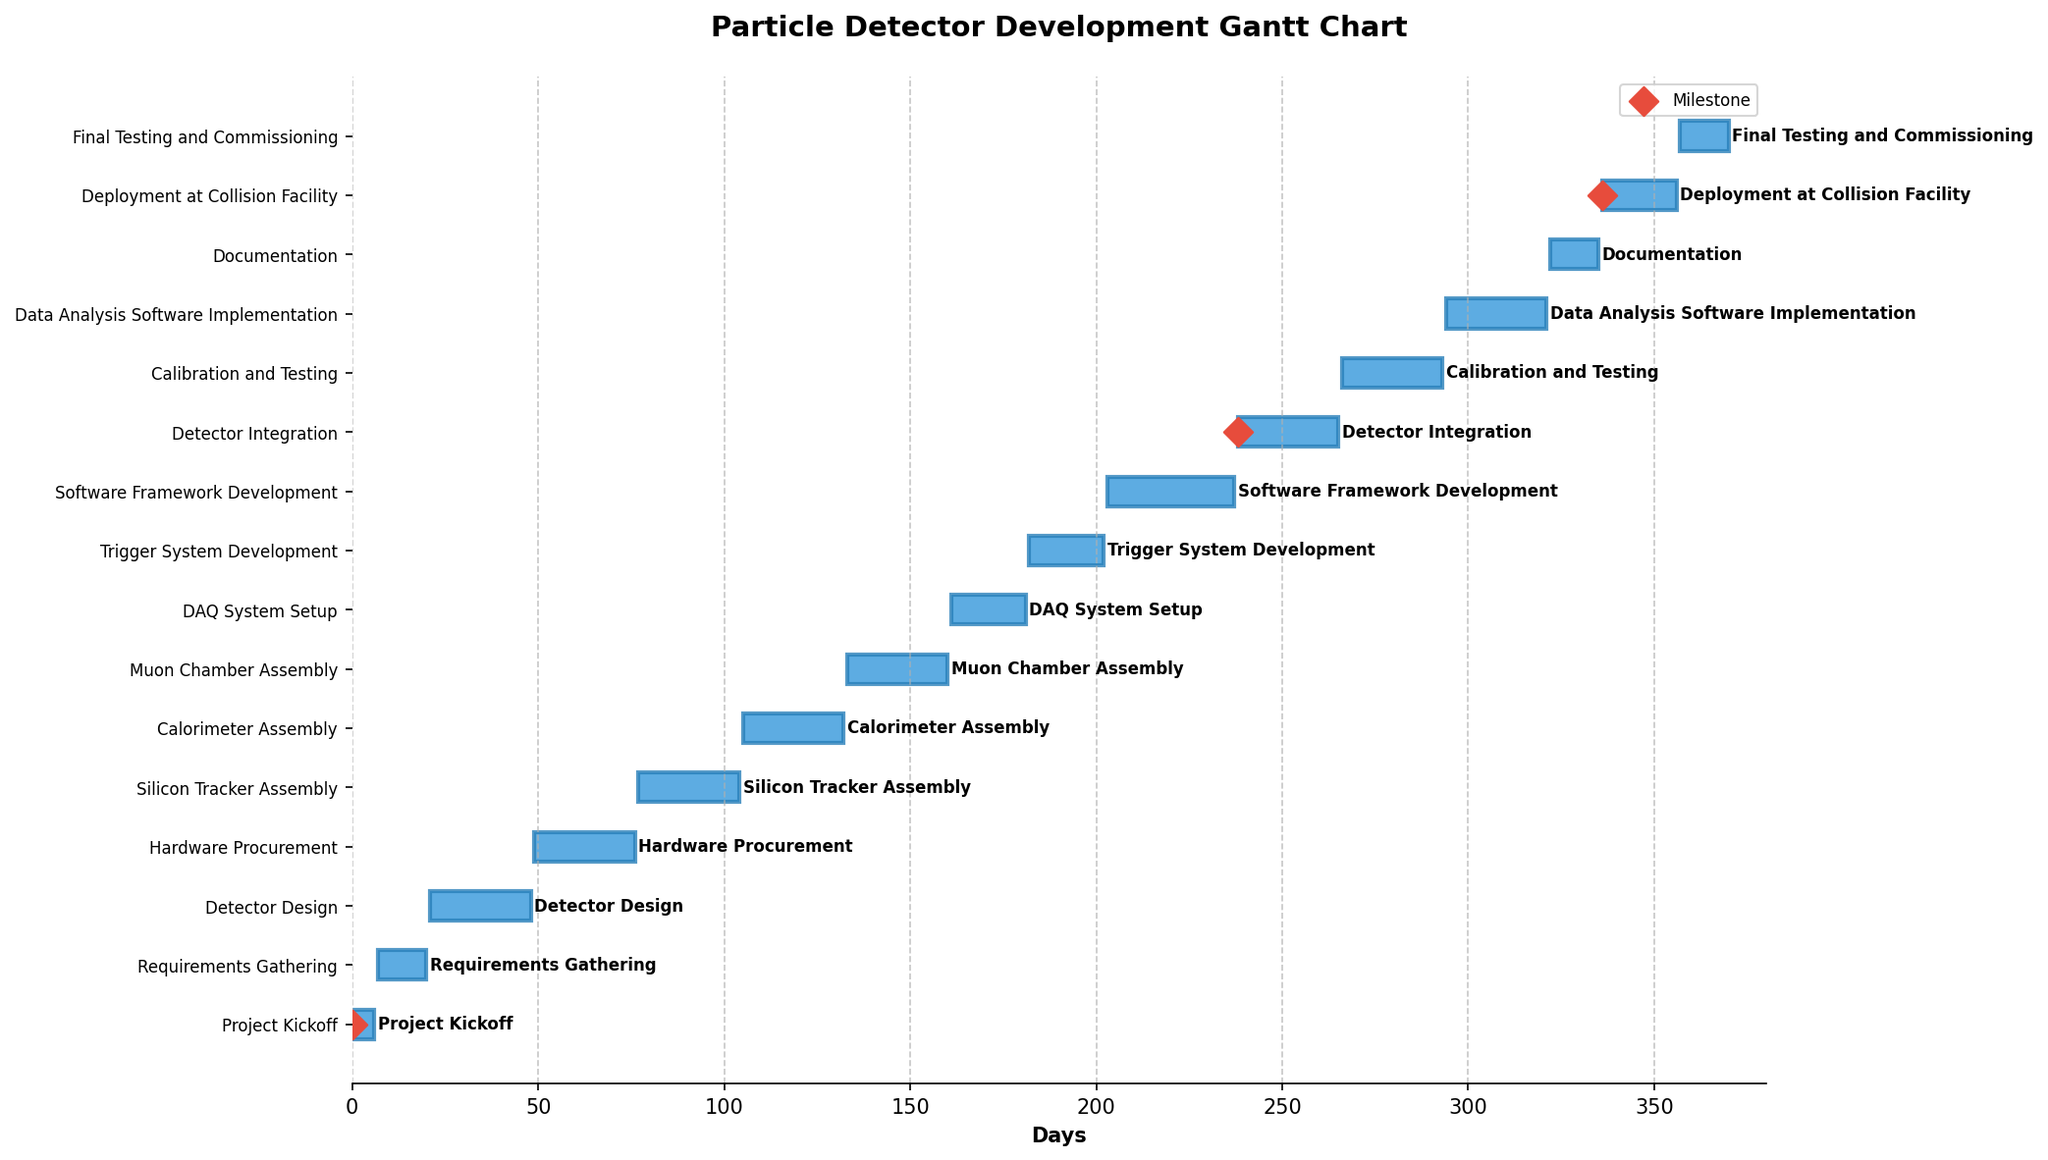Which task has the longest duration? To determine which task has the longest duration, compare the duration of each task listed along the y-axis. The Software Framework Development task spans from 2023-12-21 to 2024-01-24, covering 35 days.
Answer: Software Framework Development When does the Project Kickoff start and end? To find the start and end dates of the Project Kickoff task, look at the first bar labeled "Project Kickoff" at the top of the chart. It starts on 2023-06-01 and ends on 2023-06-07.
Answer: Starts on 2023-06-01 and ends on 2023-06-07 How many days does the Calibration and Testing task take? Find the Calibration and Testing task in the chart, and look at the duration bar to calculate its span. It starts on 2024-02-22 and ends on 2024-03-20, which is 28 days.
Answer: 28 days Which task ends just before DAQ System Setup begins? To find which task precedes DAQ System Setup, locate DAQ System Setup in the chart and look for the task directly above it. The Muon Chamber Assembly ends on 2023-11-08, just before DAQ System Setup starts on 2023-11-09.
Answer: Muon Chamber Assembly How many milestones are indicated in the chart? Count the number of diamond-shaped markers, which denote the milestones, in the chart. There are three milestones visible in the chart.
Answer: 3 milestones Which task has the shortest duration, and how long does it last? Compare the duration of each task to identify the shortest one. The Project Kickoff and Documentation tasks both have durations of 7 and 14 days, respectively, but Project Kickoff is the shortest at 7 days.
Answer: Project Kickoff, 7 days How long does the entire particle detector development project take from start to finish? Look at the overall range of dates in the chart, from the start of the Project Kickoff on 2023-06-01 to the end of the Final Testing and Commissioning on 2024-06-05. Calculating the days between these dates gives the total project duration.
Answer: 370 days Which tasks are marked as milestones, and what are their start dates? Identify the tasks with diamond-shaped markers for milestones and note their start dates. The milestones are Project Kickoff (2023-06-01), Detector Integration (2024-01-25), and Deployment at Collision Facility (2024-05-02).
Answer: Project Kickoff (2023-06-01), Detector Integration (2024-01-25), Deployment at Collision Facility (2024-05-02) What is the total duration from the start of Hardware Procurement to the end of Software Framework Development? Calculate the span starting from Hardware Procurement’s start date (2023-07-20) to the end date of Software Framework Development (2024-01-24). This period sums up to 188 days.
Answer: 188 days Which task immediately follows Silicon Tracker Assembly, and what is its duration? Find the task that begins right after the Silicon Tracker Assembly ends. The following task is Calorimeter Assembly, with a duration of 28 days.
Answer: Calorimeter Assembly, 28 days 